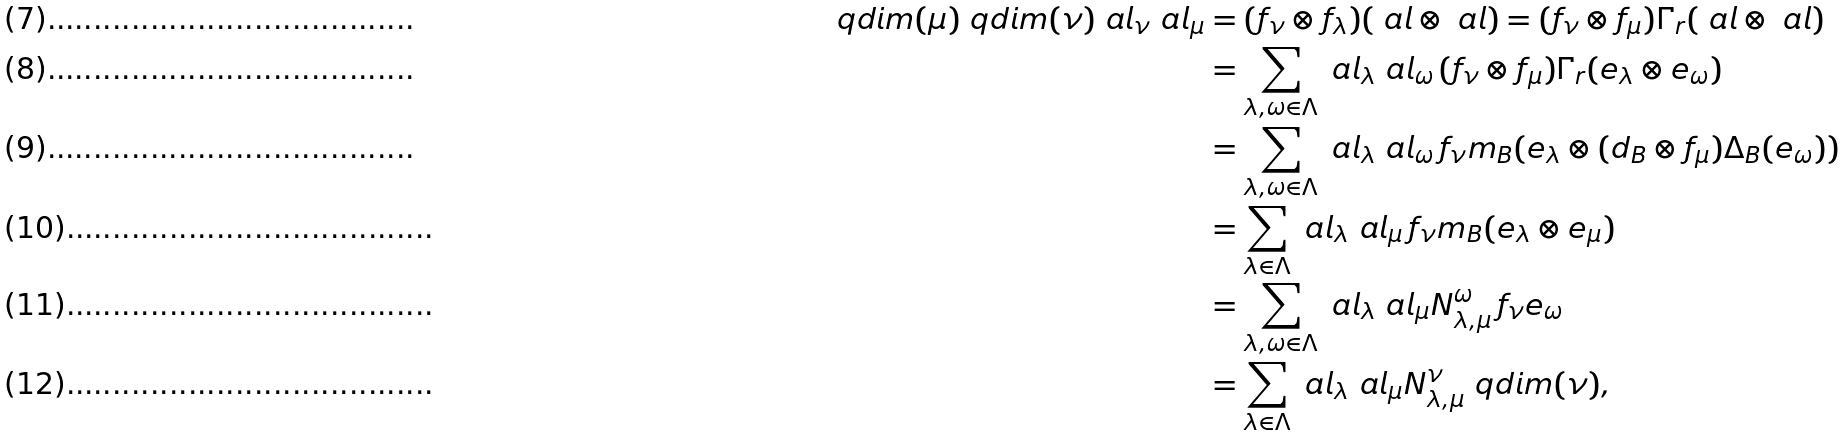<formula> <loc_0><loc_0><loc_500><loc_500>\ q d i m ( \mu ) \ q d i m ( \nu ) \ a l _ { \nu } \ a l _ { \mu } & = ( f _ { \nu } \otimes f _ { \lambda } ) ( \ a l \otimes \ a l ) = ( f _ { \nu } \otimes f _ { \mu } ) \Gamma _ { r } ( \ a l \otimes \ a l ) \\ & = \sum _ { \lambda , \omega \in \Lambda } \ a l _ { \lambda } \ a l _ { \omega } \, ( f _ { \nu } \otimes f _ { \mu } ) \Gamma _ { r } ( e _ { \lambda } \otimes e _ { \omega } ) \\ & = \sum _ { \lambda , \omega \in \Lambda } \ a l _ { \lambda } \ a l _ { \omega } \, f _ { \nu } m _ { B } ( e _ { \lambda } \otimes ( \i d _ { B } \otimes f _ { \mu } ) \Delta _ { B } ( e _ { \omega } ) ) \\ & = \sum _ { \lambda \in \Lambda } \ a l _ { \lambda } \ a l _ { \mu } \, f _ { \nu } m _ { B } ( e _ { \lambda } \otimes e _ { \mu } ) \\ & = \sum _ { \lambda , \omega \in \Lambda } \ a l _ { \lambda } \ a l _ { \mu } N _ { \lambda , \mu } ^ { \omega } \, f _ { \nu } e _ { \omega } \\ & = \sum _ { \lambda \in \Lambda } \ a l _ { \lambda } \ a l _ { \mu } N _ { \lambda , \mu } ^ { \nu } \ q d i m ( \nu ) ,</formula> 